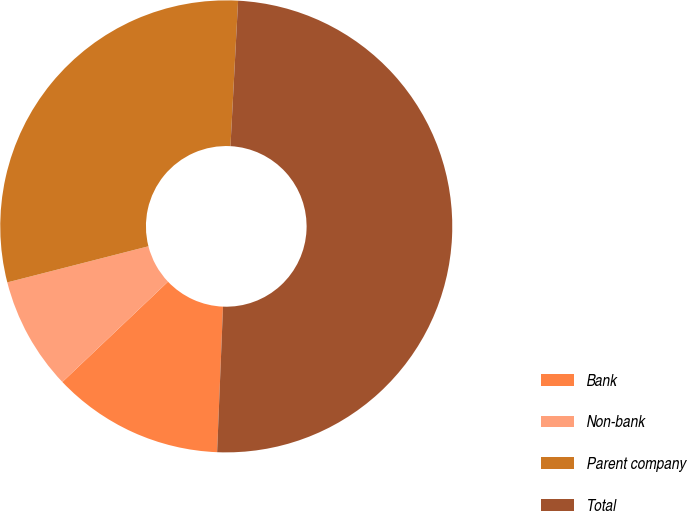<chart> <loc_0><loc_0><loc_500><loc_500><pie_chart><fcel>Bank<fcel>Non-bank<fcel>Parent company<fcel>Total<nl><fcel>12.27%<fcel>8.1%<fcel>29.82%<fcel>49.81%<nl></chart> 